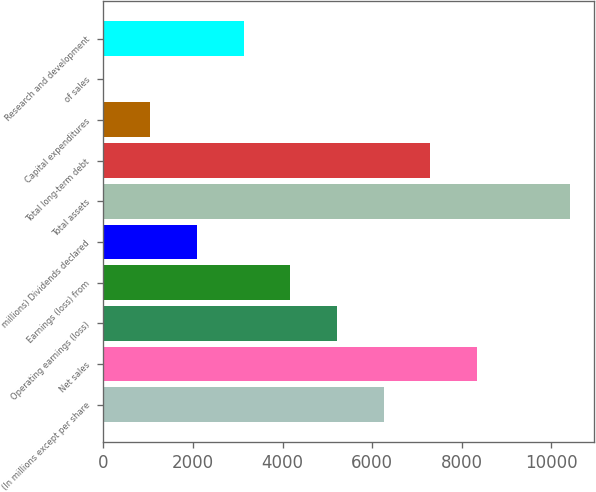Convert chart. <chart><loc_0><loc_0><loc_500><loc_500><bar_chart><fcel>(In millions except per share<fcel>Net sales<fcel>Operating earnings (loss)<fcel>Earnings (loss) from<fcel>millions) Dividends declared<fcel>Total assets<fcel>Total long-term debt<fcel>Capital expenditures<fcel>of sales<fcel>Research and development<nl><fcel>6255.04<fcel>8339.02<fcel>5213.05<fcel>4171.06<fcel>2087.08<fcel>10423<fcel>7297.03<fcel>1045.09<fcel>3.1<fcel>3129.07<nl></chart> 